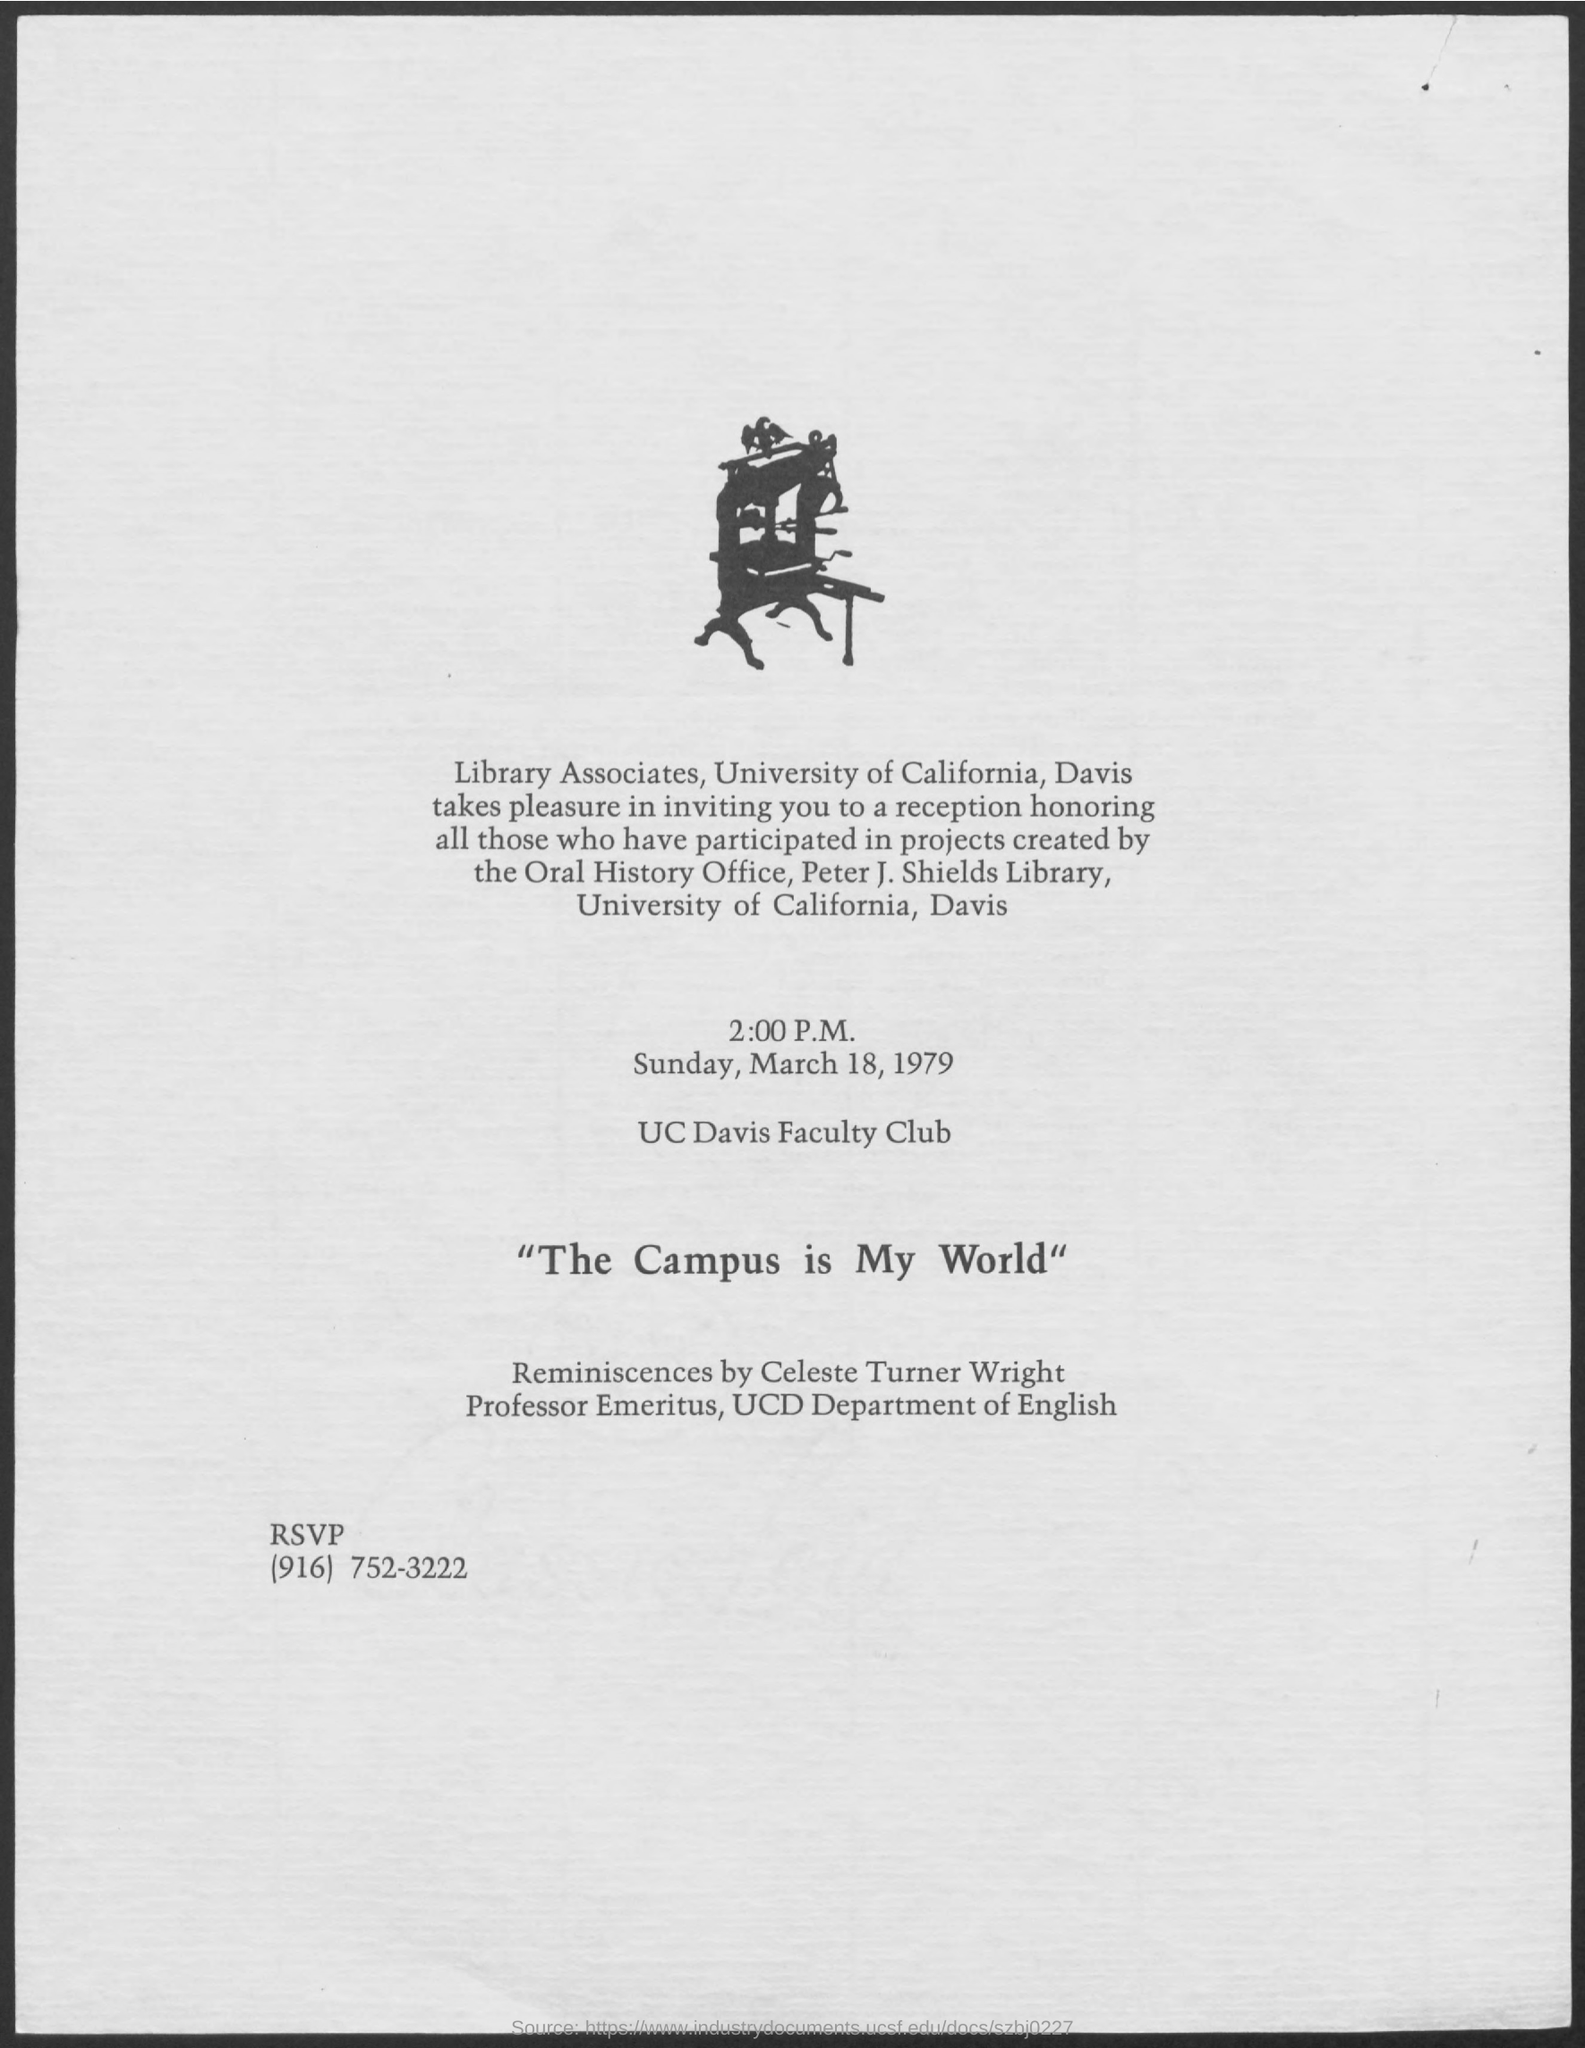Mention a couple of crucial points in this snapshot. The contact information for RSVP is (916) 752-3222. University of California, Davis (UCD) is a full form of the name of a university located in California. 